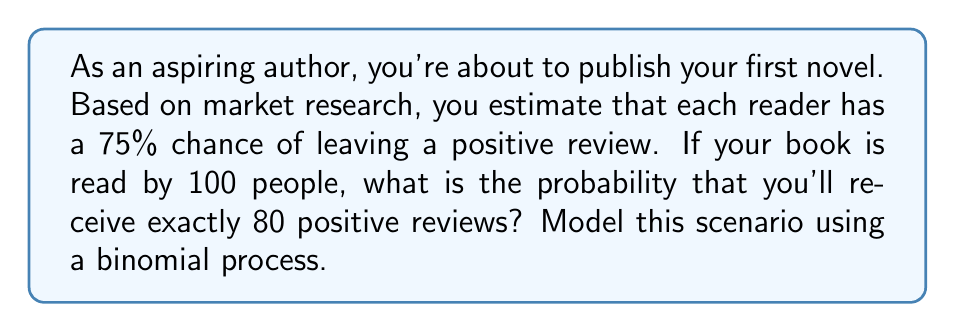Solve this math problem. Let's approach this step-by-step using the binomial distribution:

1) This scenario follows a binomial process because:
   - There's a fixed number of trials (100 readers)
   - Each trial has two possible outcomes (positive review or not)
   - The probability of success (positive review) is constant for each trial
   - The trials are independent

2) We can use the binomial probability mass function:

   $$P(X = k) = \binom{n}{k} p^k (1-p)^{n-k}$$

   Where:
   $n$ = number of trials (100 readers)
   $k$ = number of successes (80 positive reviews)
   $p$ = probability of success (0.75 chance of positive review)

3) Let's substitute our values:

   $$P(X = 80) = \binom{100}{80} (0.75)^{80} (1-0.75)^{100-80}$$

4) Simplify:

   $$P(X = 80) = \binom{100}{80} (0.75)^{80} (0.25)^{20}$$

5) Calculate the binomial coefficient:

   $$\binom{100}{80} = \frac{100!}{80!(100-80)!} = \frac{100!}{80!20!} = 5.36 \times 10^{20}$$

6) Now, let's compute the full probability:

   $$P(X = 80) = (5.36 \times 10^{20}) \times (0.75^{80}) \times (0.25^{20})$$

7) Using a calculator or computer (due to the large numbers involved):

   $$P(X = 80) \approx 0.0884 \text{ or } 8.84\%$$
Answer: 0.0884 or 8.84% 